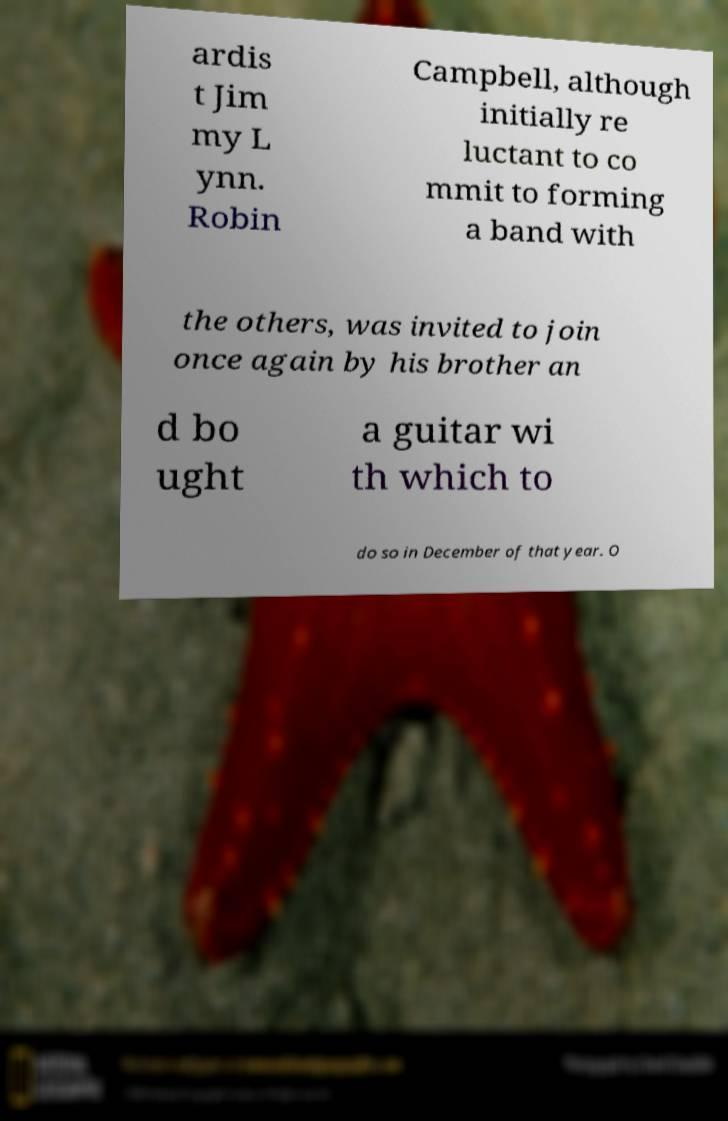Please identify and transcribe the text found in this image. ardis t Jim my L ynn. Robin Campbell, although initially re luctant to co mmit to forming a band with the others, was invited to join once again by his brother an d bo ught a guitar wi th which to do so in December of that year. O 